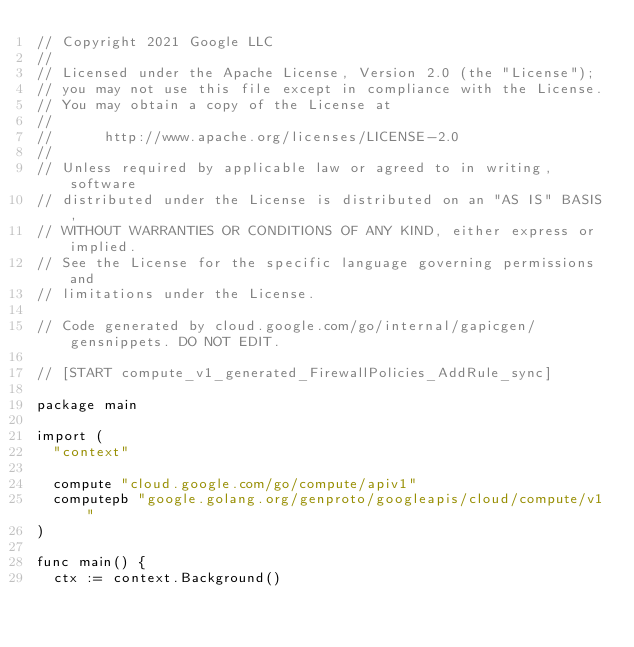Convert code to text. <code><loc_0><loc_0><loc_500><loc_500><_Go_>// Copyright 2021 Google LLC
//
// Licensed under the Apache License, Version 2.0 (the "License");
// you may not use this file except in compliance with the License.
// You may obtain a copy of the License at
//
//      http://www.apache.org/licenses/LICENSE-2.0
//
// Unless required by applicable law or agreed to in writing, software
// distributed under the License is distributed on an "AS IS" BASIS,
// WITHOUT WARRANTIES OR CONDITIONS OF ANY KIND, either express or implied.
// See the License for the specific language governing permissions and
// limitations under the License.

// Code generated by cloud.google.com/go/internal/gapicgen/gensnippets. DO NOT EDIT.

// [START compute_v1_generated_FirewallPolicies_AddRule_sync]

package main

import (
	"context"

	compute "cloud.google.com/go/compute/apiv1"
	computepb "google.golang.org/genproto/googleapis/cloud/compute/v1"
)

func main() {
	ctx := context.Background()</code> 